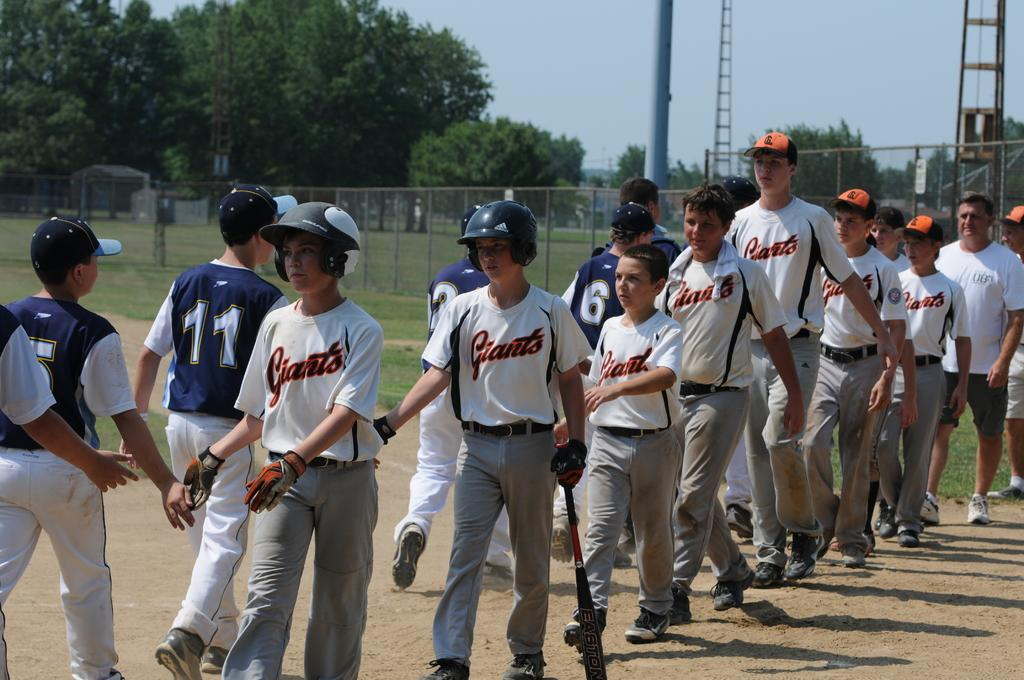How many boys are in the image? There are boys in the image, but the exact number is not specified. What are the boys doing in the image? The boys are walking on the ground and shaking hands with each other. What type of surface are the boys walking on? The boys are walking on the ground. What can be seen in the background of the image? The area is surrounded by grass, and there are trees in the vicinity. What type of rings are the boys wearing on their fingers in the image? There is no mention of rings in the image, so we cannot determine if the boys are wearing any. 